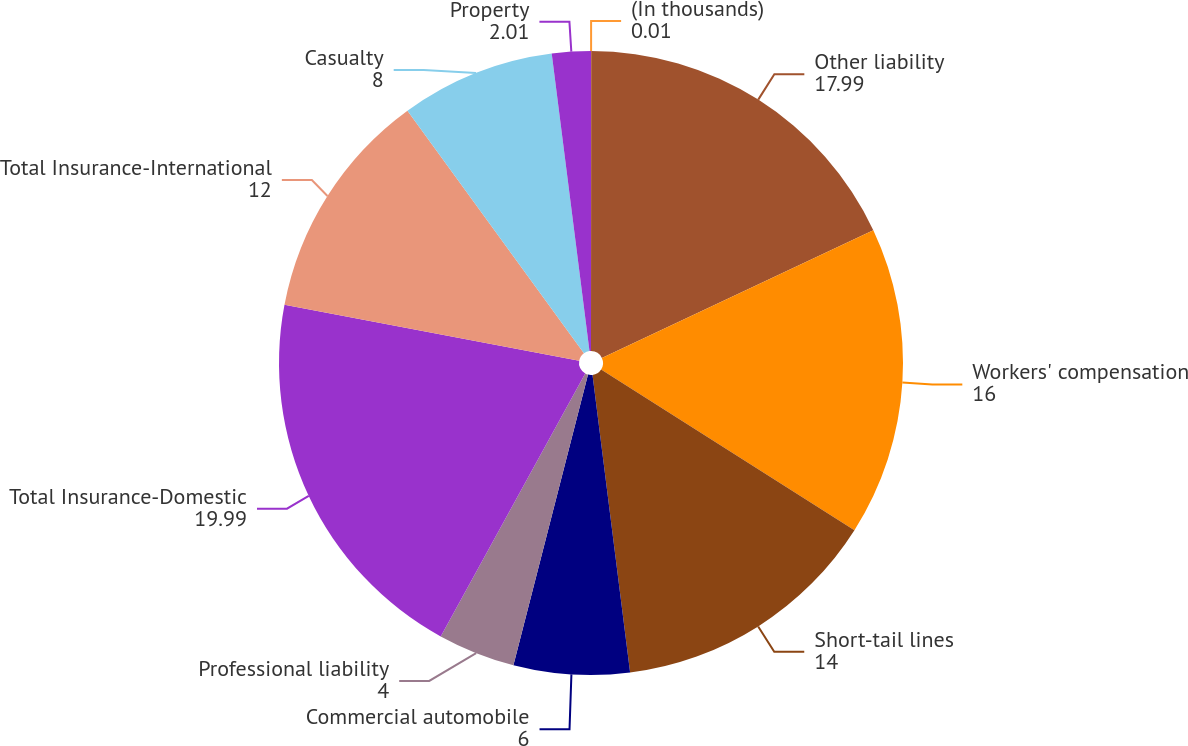Convert chart to OTSL. <chart><loc_0><loc_0><loc_500><loc_500><pie_chart><fcel>(In thousands)<fcel>Other liability<fcel>Workers' compensation<fcel>Short-tail lines<fcel>Commercial automobile<fcel>Professional liability<fcel>Total Insurance-Domestic<fcel>Total Insurance-International<fcel>Casualty<fcel>Property<nl><fcel>0.01%<fcel>17.99%<fcel>16.0%<fcel>14.0%<fcel>6.0%<fcel>4.0%<fcel>19.99%<fcel>12.0%<fcel>8.0%<fcel>2.01%<nl></chart> 